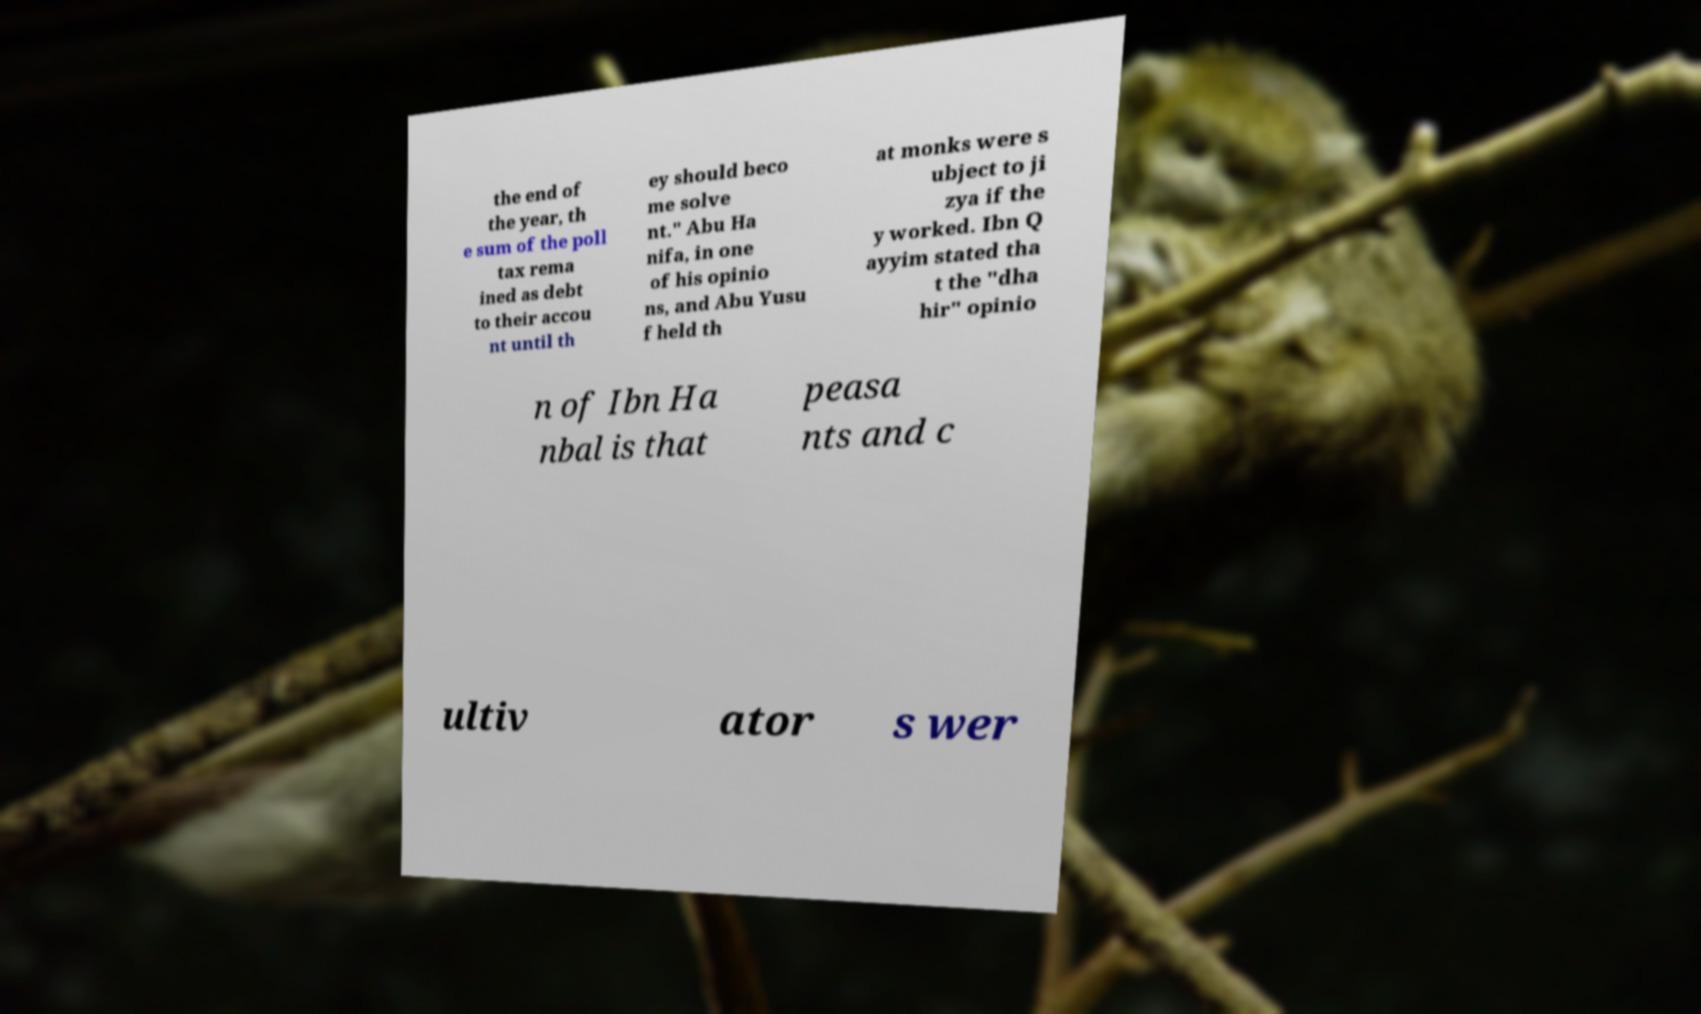For documentation purposes, I need the text within this image transcribed. Could you provide that? the end of the year, th e sum of the poll tax rema ined as debt to their accou nt until th ey should beco me solve nt." Abu Ha nifa, in one of his opinio ns, and Abu Yusu f held th at monks were s ubject to ji zya if the y worked. Ibn Q ayyim stated tha t the "dha hir" opinio n of Ibn Ha nbal is that peasa nts and c ultiv ator s wer 